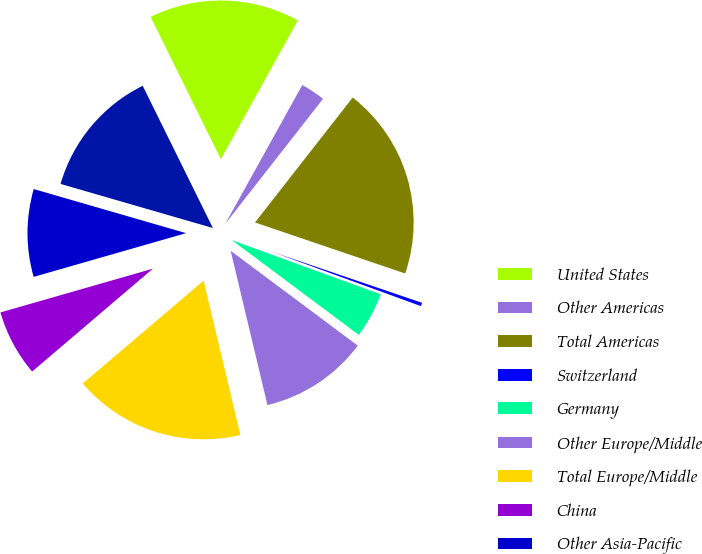Convert chart to OTSL. <chart><loc_0><loc_0><loc_500><loc_500><pie_chart><fcel>United States<fcel>Other Americas<fcel>Total Americas<fcel>Switzerland<fcel>Germany<fcel>Other Europe/Middle<fcel>Total Europe/Middle<fcel>China<fcel>Other Asia-Pacific<fcel>Total Asia-Pacific<nl><fcel>15.36%<fcel>2.5%<fcel>19.65%<fcel>0.35%<fcel>4.64%<fcel>11.07%<fcel>17.5%<fcel>6.78%<fcel>8.93%<fcel>13.22%<nl></chart> 